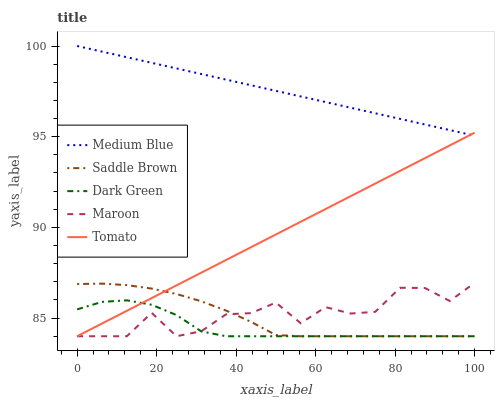Does Saddle Brown have the minimum area under the curve?
Answer yes or no. No. Does Saddle Brown have the maximum area under the curve?
Answer yes or no. No. Is Saddle Brown the smoothest?
Answer yes or no. No. Is Saddle Brown the roughest?
Answer yes or no. No. Does Medium Blue have the lowest value?
Answer yes or no. No. Does Saddle Brown have the highest value?
Answer yes or no. No. Is Saddle Brown less than Medium Blue?
Answer yes or no. Yes. Is Medium Blue greater than Maroon?
Answer yes or no. Yes. Does Saddle Brown intersect Medium Blue?
Answer yes or no. No. 